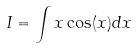<formula> <loc_0><loc_0><loc_500><loc_500>I = \int x \cos ( x ) d x</formula> 